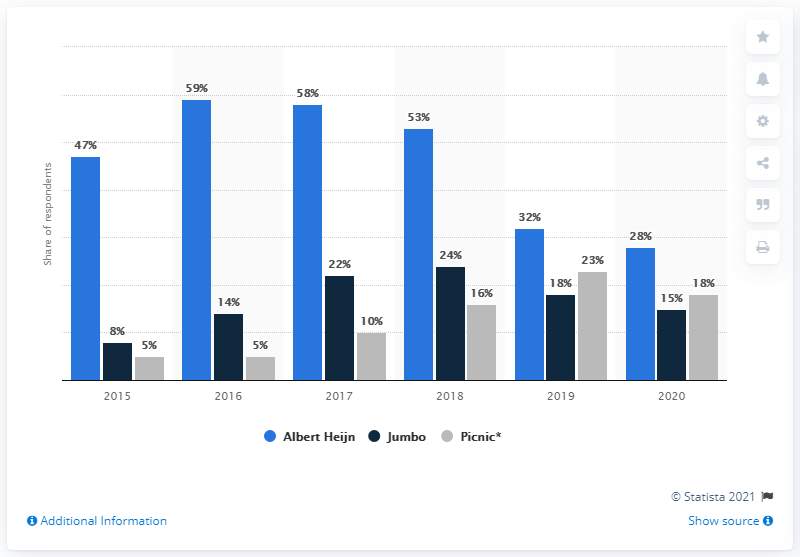Give some essential details in this illustration. The difference in market share between Albert Heijn and Picnic has varied over the years, with Albert Heijn consistently holding the highest market share while Picnic has consistently held the minimum market share. In 2018, Jumbo recorded the highest market share among all years over the years. According to data from 2019, Picnic's market share was approximately 23%. 